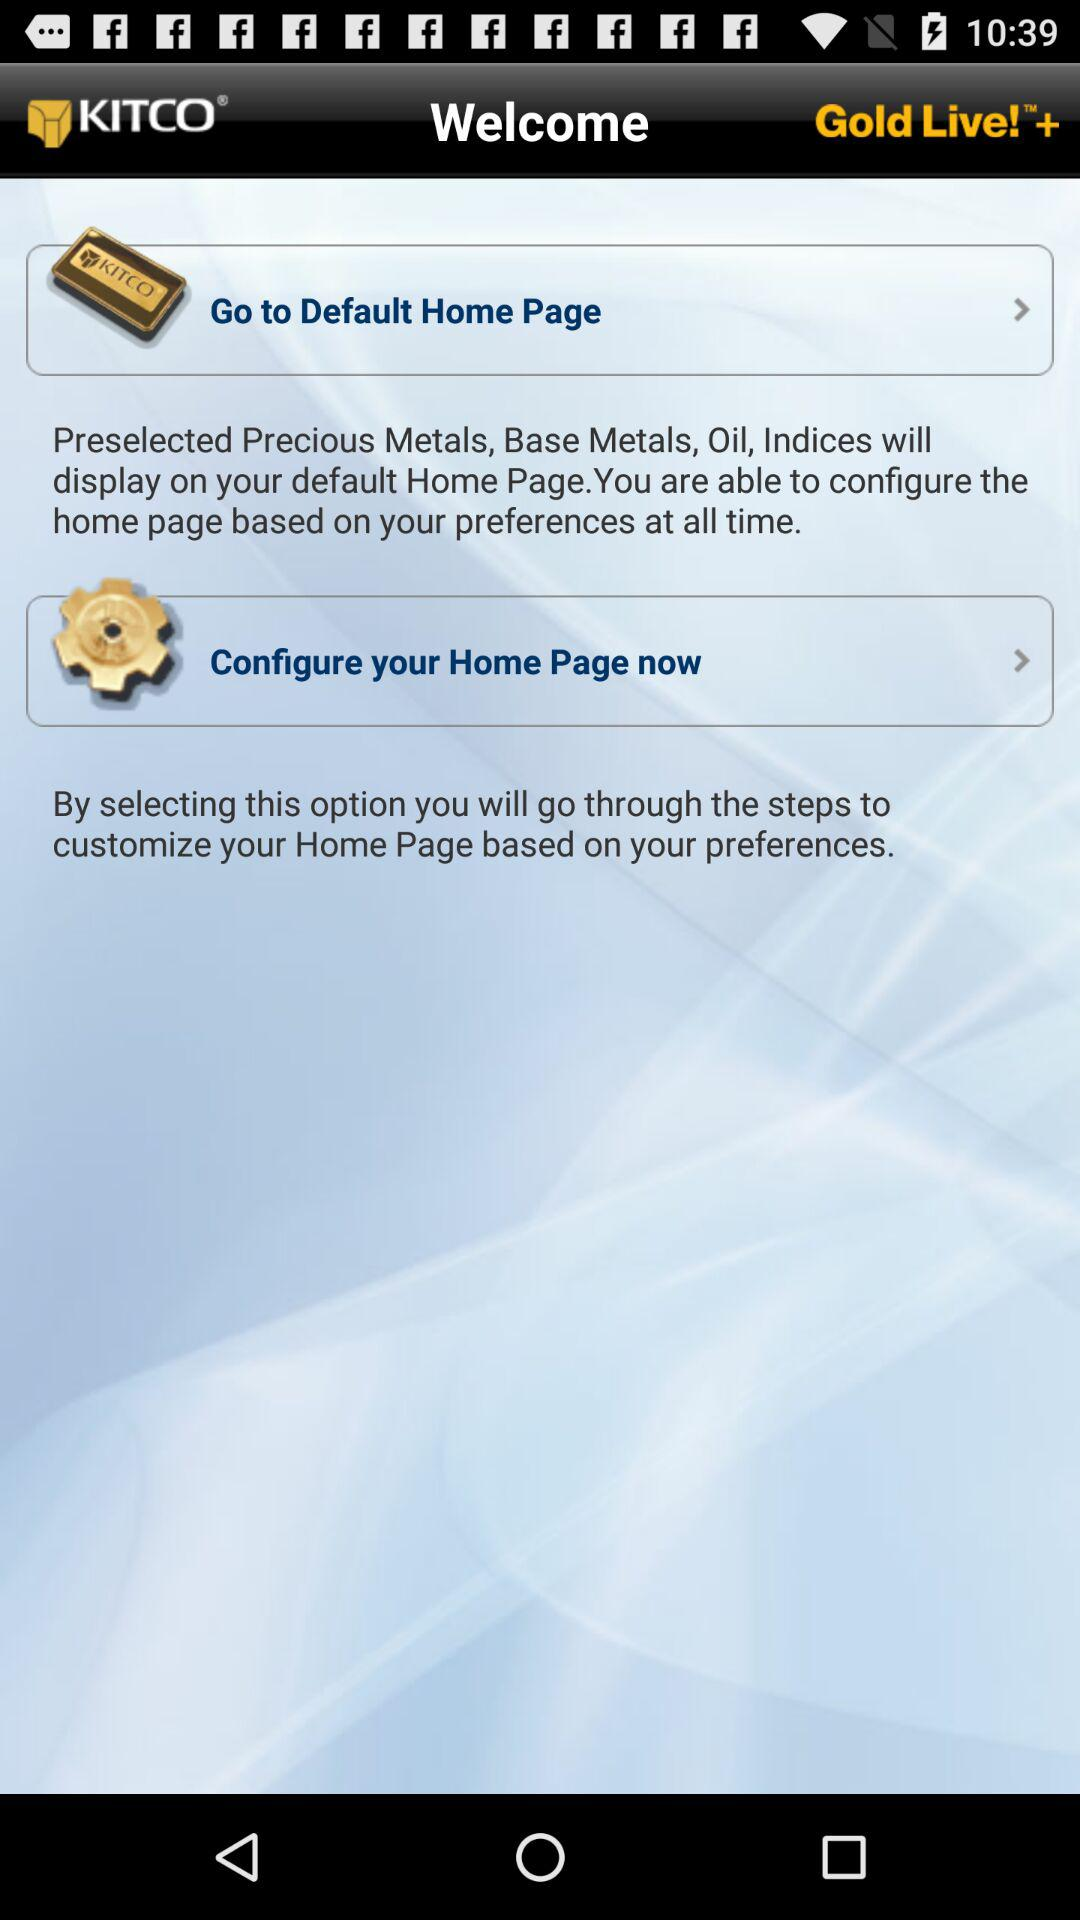What is the application name? The application name is KITCO. 